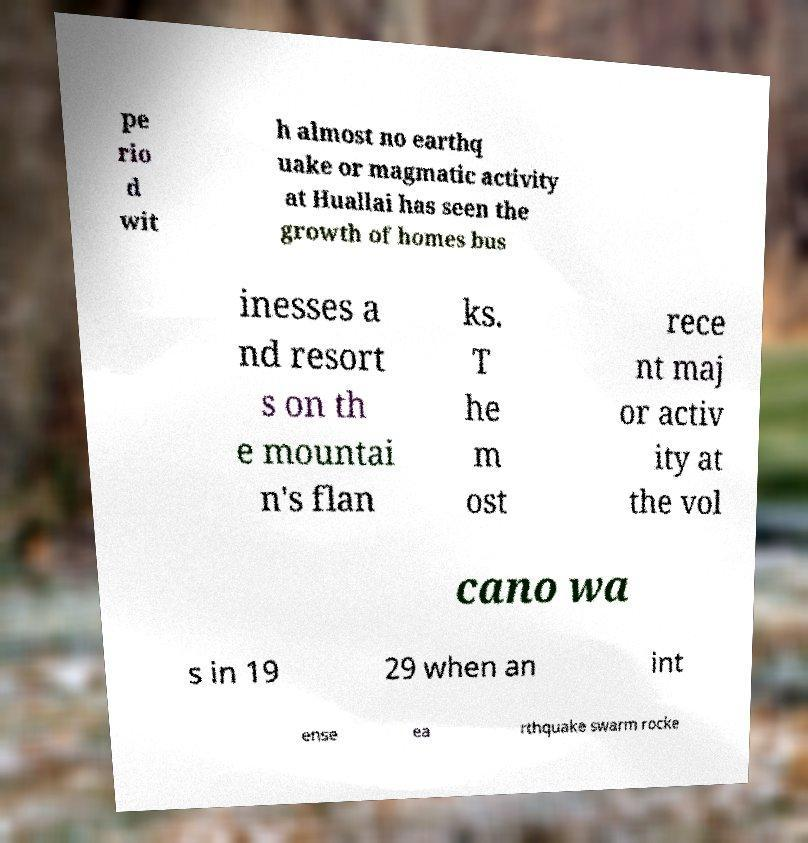Can you read and provide the text displayed in the image?This photo seems to have some interesting text. Can you extract and type it out for me? pe rio d wit h almost no earthq uake or magmatic activity at Huallai has seen the growth of homes bus inesses a nd resort s on th e mountai n's flan ks. T he m ost rece nt maj or activ ity at the vol cano wa s in 19 29 when an int ense ea rthquake swarm rocke 